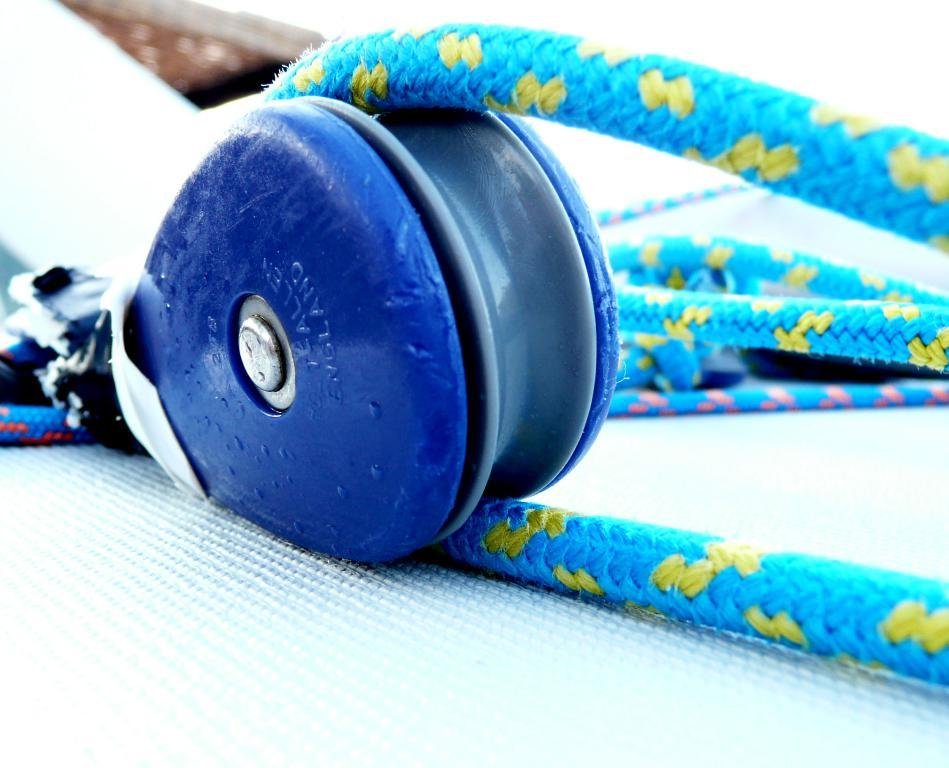What can be seen in the image that is used for tying or securing? There are ropes in the image that can be used for tying or securing. What is the color of the platform on which objects are placed in the image? The platform on which objects are placed in the image is white. Can you describe the background of the image? The background of the image is blurry. What type of grain is being harvested in the image? There is no grain or harvesting activity present in the image. Which direction is the society moving in the image? There is no society or directional movement depicted in the image. 